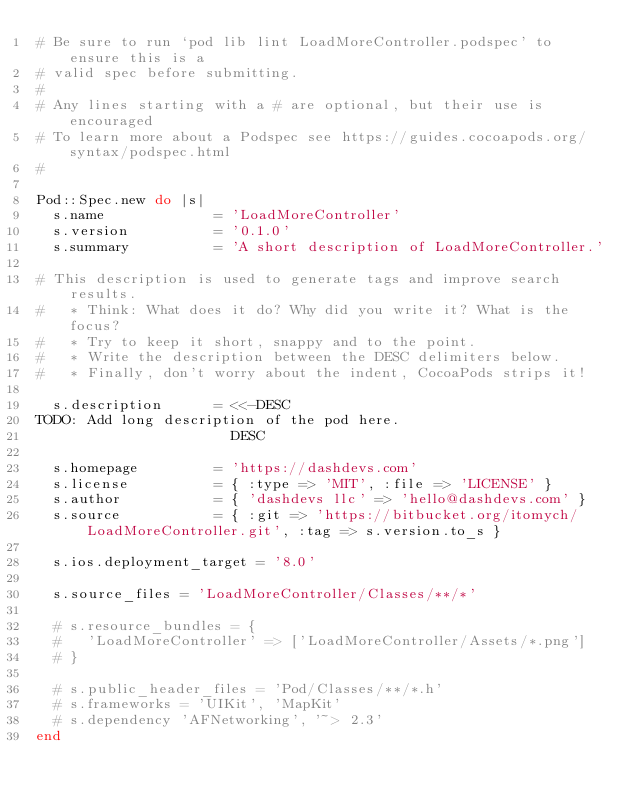<code> <loc_0><loc_0><loc_500><loc_500><_Ruby_># Be sure to run `pod lib lint LoadMoreController.podspec' to ensure this is a
# valid spec before submitting.
#
# Any lines starting with a # are optional, but their use is encouraged
# To learn more about a Podspec see https://guides.cocoapods.org/syntax/podspec.html
#

Pod::Spec.new do |s|
  s.name             = 'LoadMoreController'
  s.version          = '0.1.0'
  s.summary          = 'A short description of LoadMoreController.'

# This description is used to generate tags and improve search results.
#   * Think: What does it do? Why did you write it? What is the focus?
#   * Try to keep it short, snappy and to the point.
#   * Write the description between the DESC delimiters below.
#   * Finally, don't worry about the indent, CocoaPods strips it!

  s.description      = <<-DESC
TODO: Add long description of the pod here.
                       DESC

  s.homepage         = 'https://dashdevs.com'
  s.license          = { :type => 'MIT', :file => 'LICENSE' }
  s.author           = { 'dashdevs llc' => 'hello@dashdevs.com' }
  s.source           = { :git => 'https://bitbucket.org/itomych/LoadMoreController.git', :tag => s.version.to_s }

  s.ios.deployment_target = '8.0'

  s.source_files = 'LoadMoreController/Classes/**/*'
  
  # s.resource_bundles = {
  #   'LoadMoreController' => ['LoadMoreController/Assets/*.png']
  # }

  # s.public_header_files = 'Pod/Classes/**/*.h'
  # s.frameworks = 'UIKit', 'MapKit'
  # s.dependency 'AFNetworking', '~> 2.3'
end
</code> 